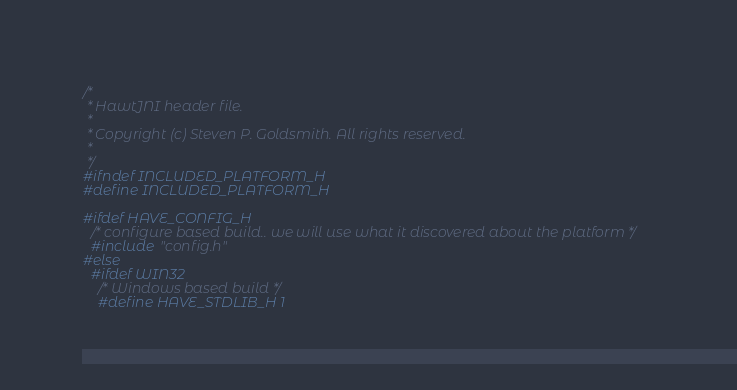Convert code to text. <code><loc_0><loc_0><loc_500><loc_500><_C_>/*
 * HawtJNI header file.
 *
 * Copyright (c) Steven P. Goldsmith. All rights reserved.
 *
 */
#ifndef INCLUDED_PLATFORM_H
#define INCLUDED_PLATFORM_H

#ifdef HAVE_CONFIG_H
  /* configure based build.. we will use what it discovered about the platform */
  #include "config.h"
#else
  #ifdef WIN32
    /* Windows based build */
    #define HAVE_STDLIB_H 1</code> 